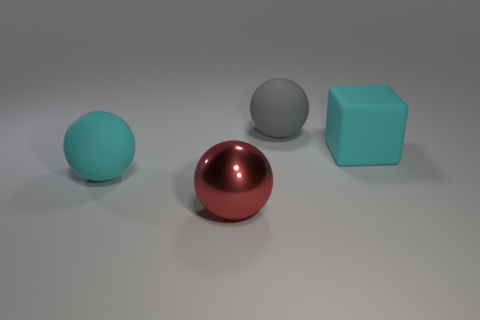What time of day does the lighting in the image suggest, and why? The lighting in the image suggests an artificial interior environment rather than a natural outdoor setting. The soft shadows and diffused light with no strong directional source imply it's likely illuminated by artificial studio lights or indirect daylight in an indoor setting. 